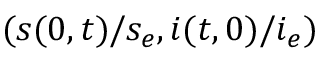<formula> <loc_0><loc_0><loc_500><loc_500>( s ( 0 , t ) / s _ { e } , i ( t , 0 ) / i _ { e } )</formula> 